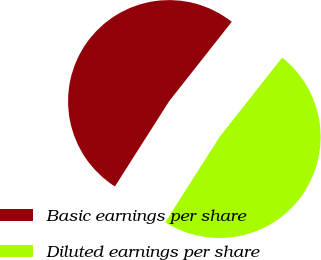Convert chart to OTSL. <chart><loc_0><loc_0><loc_500><loc_500><pie_chart><fcel>Basic earnings per share<fcel>Diluted earnings per share<nl><fcel>51.61%<fcel>48.39%<nl></chart> 